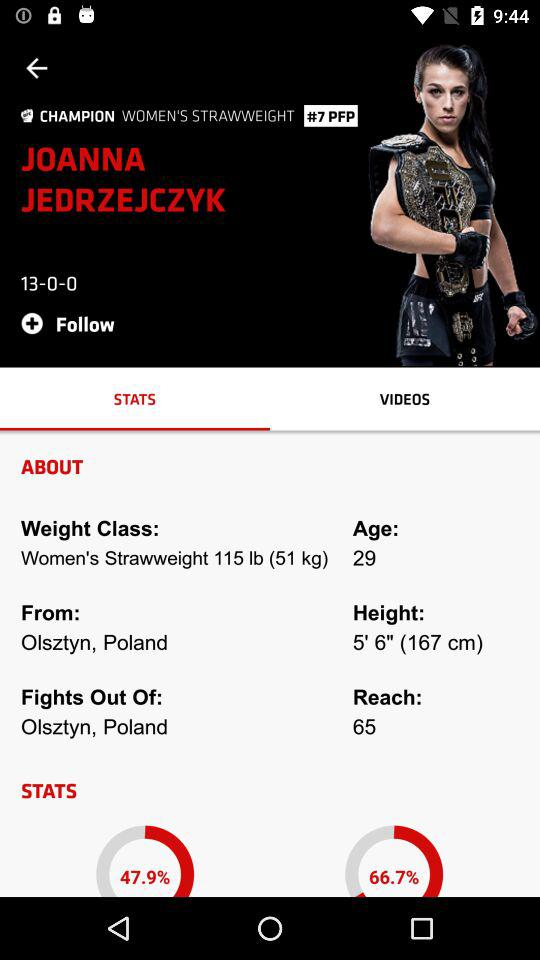Which tab is selected? The selected tab is "STATS". 